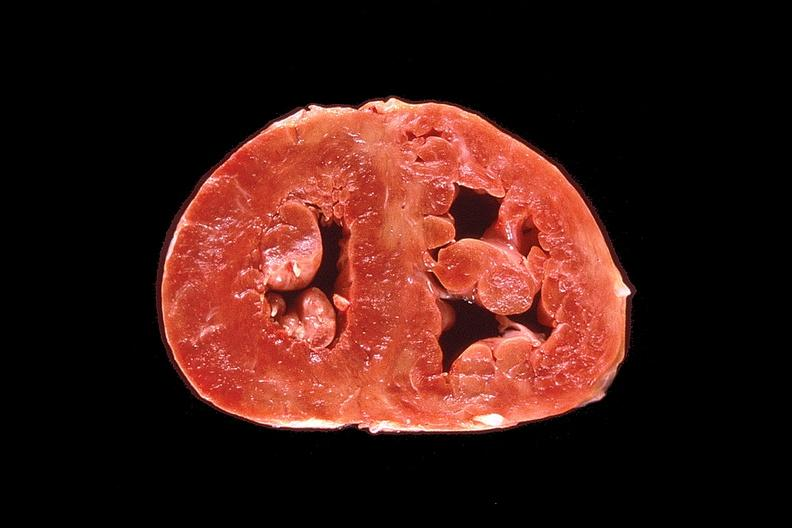what is present?
Answer the question using a single word or phrase. Cardiovascular 